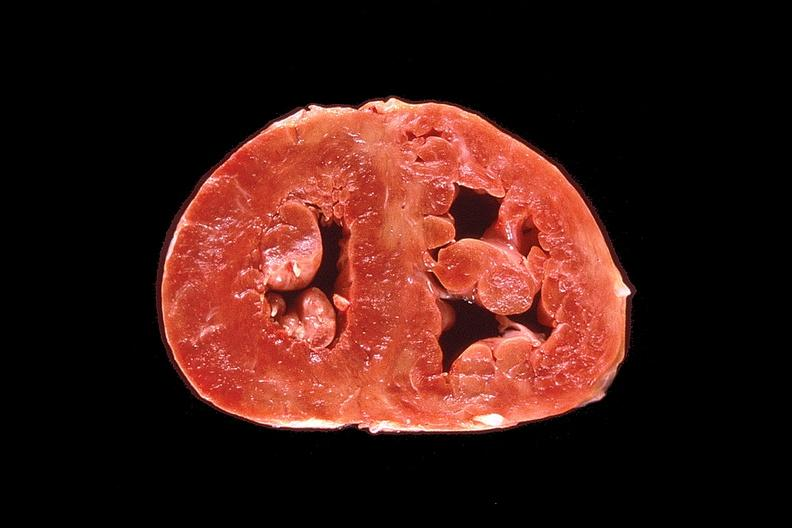what is present?
Answer the question using a single word or phrase. Cardiovascular 